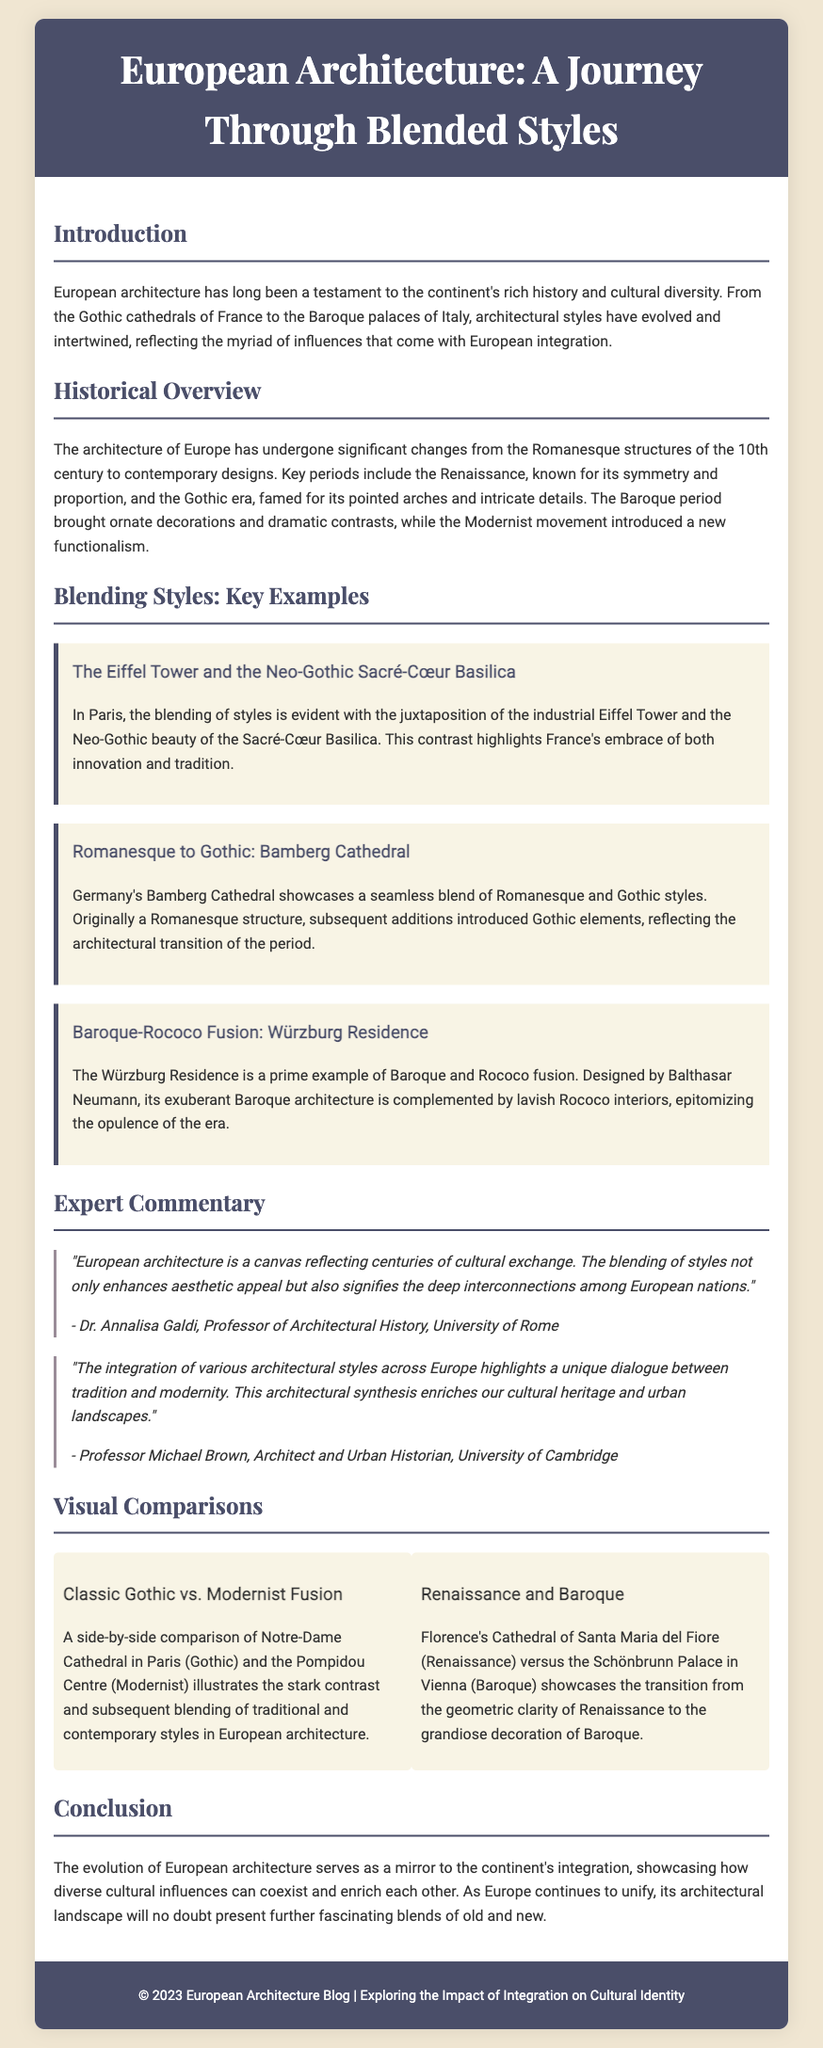What is the title of the document? The title is prominently featured at the top of the document, indicating the subject matter focus.
Answer: European Architecture: A Journey Through Blended Styles Who is the author of the expert quote on cultural exchange? The document lists Dr. Annalisa Galdi as the author of the first expert quote within the Expert Commentary section.
Answer: Dr. Annalisa Galdi What architectural styles are compared in the visual comparison titled "Renaissance and Baroque"? The visual comparison describes the styles examined by referencing specific architectural works representative of those styles.
Answer: Renaissance and Baroque Which cathedral is mentioned as a classic Gothic example? The Notre-Dame Cathedral in Paris is highlighted as a classic Gothic style in the document's visual comparisons.
Answer: Notre-Dame Cathedral What period is known for its symmetry and proportion? The document outlines key periods in architectural evolution, attributing symmetry and proportion specifically to one significant period.
Answer: Renaissance Which architectural element is characteristic of the Gothic era? The document identifies a specific architectural feature that defines the Gothic period by focusing on its unique style elements.
Answer: Pointed arches What is the main theme discussed throughout the document? The document's introduction describes a central theme that reflects the overall explorative content of the architectural styles over time.
Answer: Blended styles Who designed the Würzburg Residence? The document attributes the design of this specific architectural marvel to a notable architect, mentioned in the blending styles section.
Answer: Balthasar Neumann 